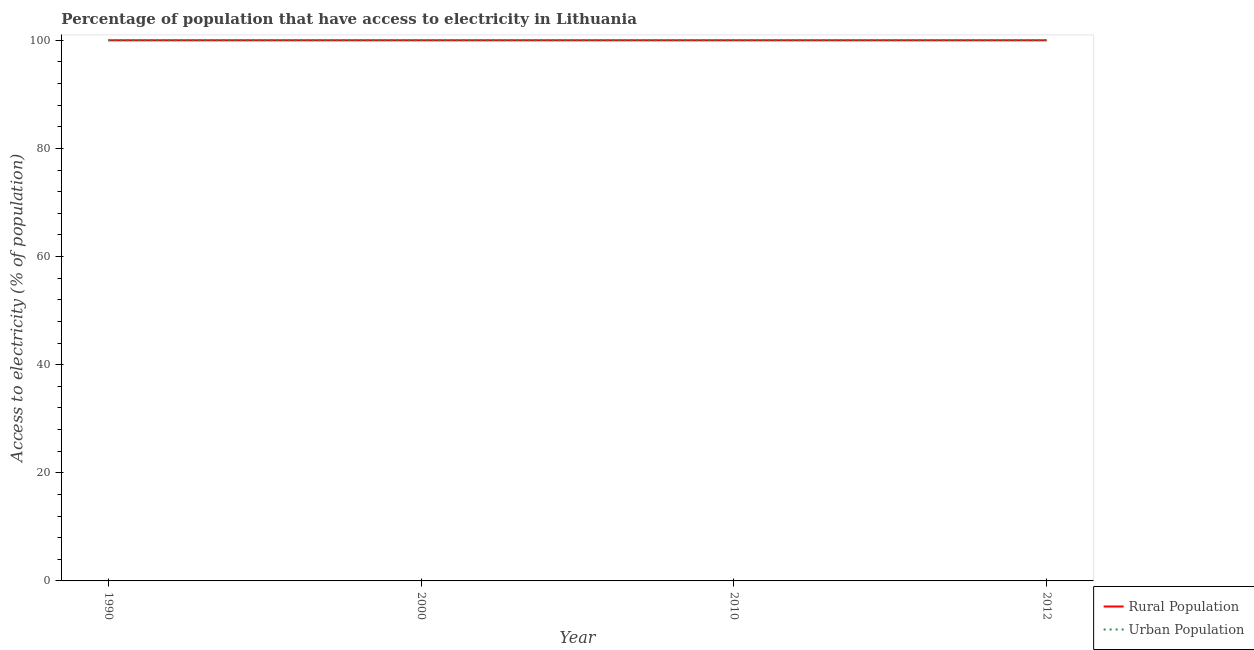Does the line corresponding to percentage of rural population having access to electricity intersect with the line corresponding to percentage of urban population having access to electricity?
Offer a terse response. Yes. Is the number of lines equal to the number of legend labels?
Offer a terse response. Yes. What is the percentage of urban population having access to electricity in 1990?
Make the answer very short. 100. Across all years, what is the maximum percentage of urban population having access to electricity?
Provide a succinct answer. 100. Across all years, what is the minimum percentage of urban population having access to electricity?
Your answer should be compact. 100. In which year was the percentage of urban population having access to electricity minimum?
Your answer should be very brief. 1990. What is the total percentage of urban population having access to electricity in the graph?
Provide a succinct answer. 400. What is the difference between the percentage of urban population having access to electricity in 2010 and the percentage of rural population having access to electricity in 2000?
Provide a succinct answer. 0. What is the average percentage of rural population having access to electricity per year?
Your answer should be very brief. 100. What is the ratio of the percentage of urban population having access to electricity in 2000 to that in 2010?
Your answer should be very brief. 1. Is the difference between the percentage of urban population having access to electricity in 2000 and 2010 greater than the difference between the percentage of rural population having access to electricity in 2000 and 2010?
Keep it short and to the point. No. What is the difference between the highest and the second highest percentage of urban population having access to electricity?
Your answer should be very brief. 0. What is the difference between the highest and the lowest percentage of urban population having access to electricity?
Your answer should be very brief. 0. In how many years, is the percentage of rural population having access to electricity greater than the average percentage of rural population having access to electricity taken over all years?
Offer a very short reply. 0. Is the sum of the percentage of rural population having access to electricity in 2000 and 2012 greater than the maximum percentage of urban population having access to electricity across all years?
Your answer should be very brief. Yes. How many years are there in the graph?
Your answer should be very brief. 4. Are the values on the major ticks of Y-axis written in scientific E-notation?
Give a very brief answer. No. Does the graph contain grids?
Provide a succinct answer. No. How are the legend labels stacked?
Offer a terse response. Vertical. What is the title of the graph?
Make the answer very short. Percentage of population that have access to electricity in Lithuania. What is the label or title of the X-axis?
Offer a very short reply. Year. What is the label or title of the Y-axis?
Make the answer very short. Access to electricity (% of population). What is the Access to electricity (% of population) of Rural Population in 1990?
Give a very brief answer. 100. What is the Access to electricity (% of population) of Urban Population in 1990?
Offer a terse response. 100. What is the Access to electricity (% of population) of Rural Population in 2000?
Offer a very short reply. 100. What is the Access to electricity (% of population) in Rural Population in 2010?
Give a very brief answer. 100. What is the Access to electricity (% of population) of Urban Population in 2010?
Your answer should be compact. 100. What is the Access to electricity (% of population) of Urban Population in 2012?
Your response must be concise. 100. Across all years, what is the maximum Access to electricity (% of population) in Rural Population?
Your answer should be very brief. 100. What is the difference between the Access to electricity (% of population) in Urban Population in 1990 and that in 2000?
Provide a succinct answer. 0. What is the difference between the Access to electricity (% of population) in Urban Population in 1990 and that in 2010?
Ensure brevity in your answer.  0. What is the difference between the Access to electricity (% of population) of Rural Population in 1990 and that in 2012?
Offer a very short reply. 0. What is the difference between the Access to electricity (% of population) in Rural Population in 2000 and that in 2012?
Offer a very short reply. 0. What is the difference between the Access to electricity (% of population) in Rural Population in 1990 and the Access to electricity (% of population) in Urban Population in 2000?
Give a very brief answer. 0. What is the difference between the Access to electricity (% of population) in Rural Population in 1990 and the Access to electricity (% of population) in Urban Population in 2010?
Your response must be concise. 0. What is the difference between the Access to electricity (% of population) in Rural Population in 2010 and the Access to electricity (% of population) in Urban Population in 2012?
Make the answer very short. 0. What is the average Access to electricity (% of population) of Rural Population per year?
Your response must be concise. 100. What is the average Access to electricity (% of population) in Urban Population per year?
Make the answer very short. 100. In the year 2010, what is the difference between the Access to electricity (% of population) of Rural Population and Access to electricity (% of population) of Urban Population?
Keep it short and to the point. 0. In the year 2012, what is the difference between the Access to electricity (% of population) of Rural Population and Access to electricity (% of population) of Urban Population?
Offer a very short reply. 0. What is the ratio of the Access to electricity (% of population) in Rural Population in 1990 to that in 2000?
Make the answer very short. 1. What is the ratio of the Access to electricity (% of population) in Urban Population in 1990 to that in 2000?
Your answer should be very brief. 1. What is the ratio of the Access to electricity (% of population) in Rural Population in 1990 to that in 2010?
Provide a succinct answer. 1. What is the ratio of the Access to electricity (% of population) of Urban Population in 1990 to that in 2010?
Provide a succinct answer. 1. What is the ratio of the Access to electricity (% of population) in Rural Population in 1990 to that in 2012?
Give a very brief answer. 1. What is the ratio of the Access to electricity (% of population) in Urban Population in 1990 to that in 2012?
Offer a very short reply. 1. What is the ratio of the Access to electricity (% of population) of Rural Population in 2000 to that in 2010?
Make the answer very short. 1. What is the ratio of the Access to electricity (% of population) of Rural Population in 2010 to that in 2012?
Provide a succinct answer. 1. What is the ratio of the Access to electricity (% of population) in Urban Population in 2010 to that in 2012?
Ensure brevity in your answer.  1. What is the difference between the highest and the second highest Access to electricity (% of population) in Urban Population?
Your answer should be compact. 0. What is the difference between the highest and the lowest Access to electricity (% of population) of Rural Population?
Your response must be concise. 0. 